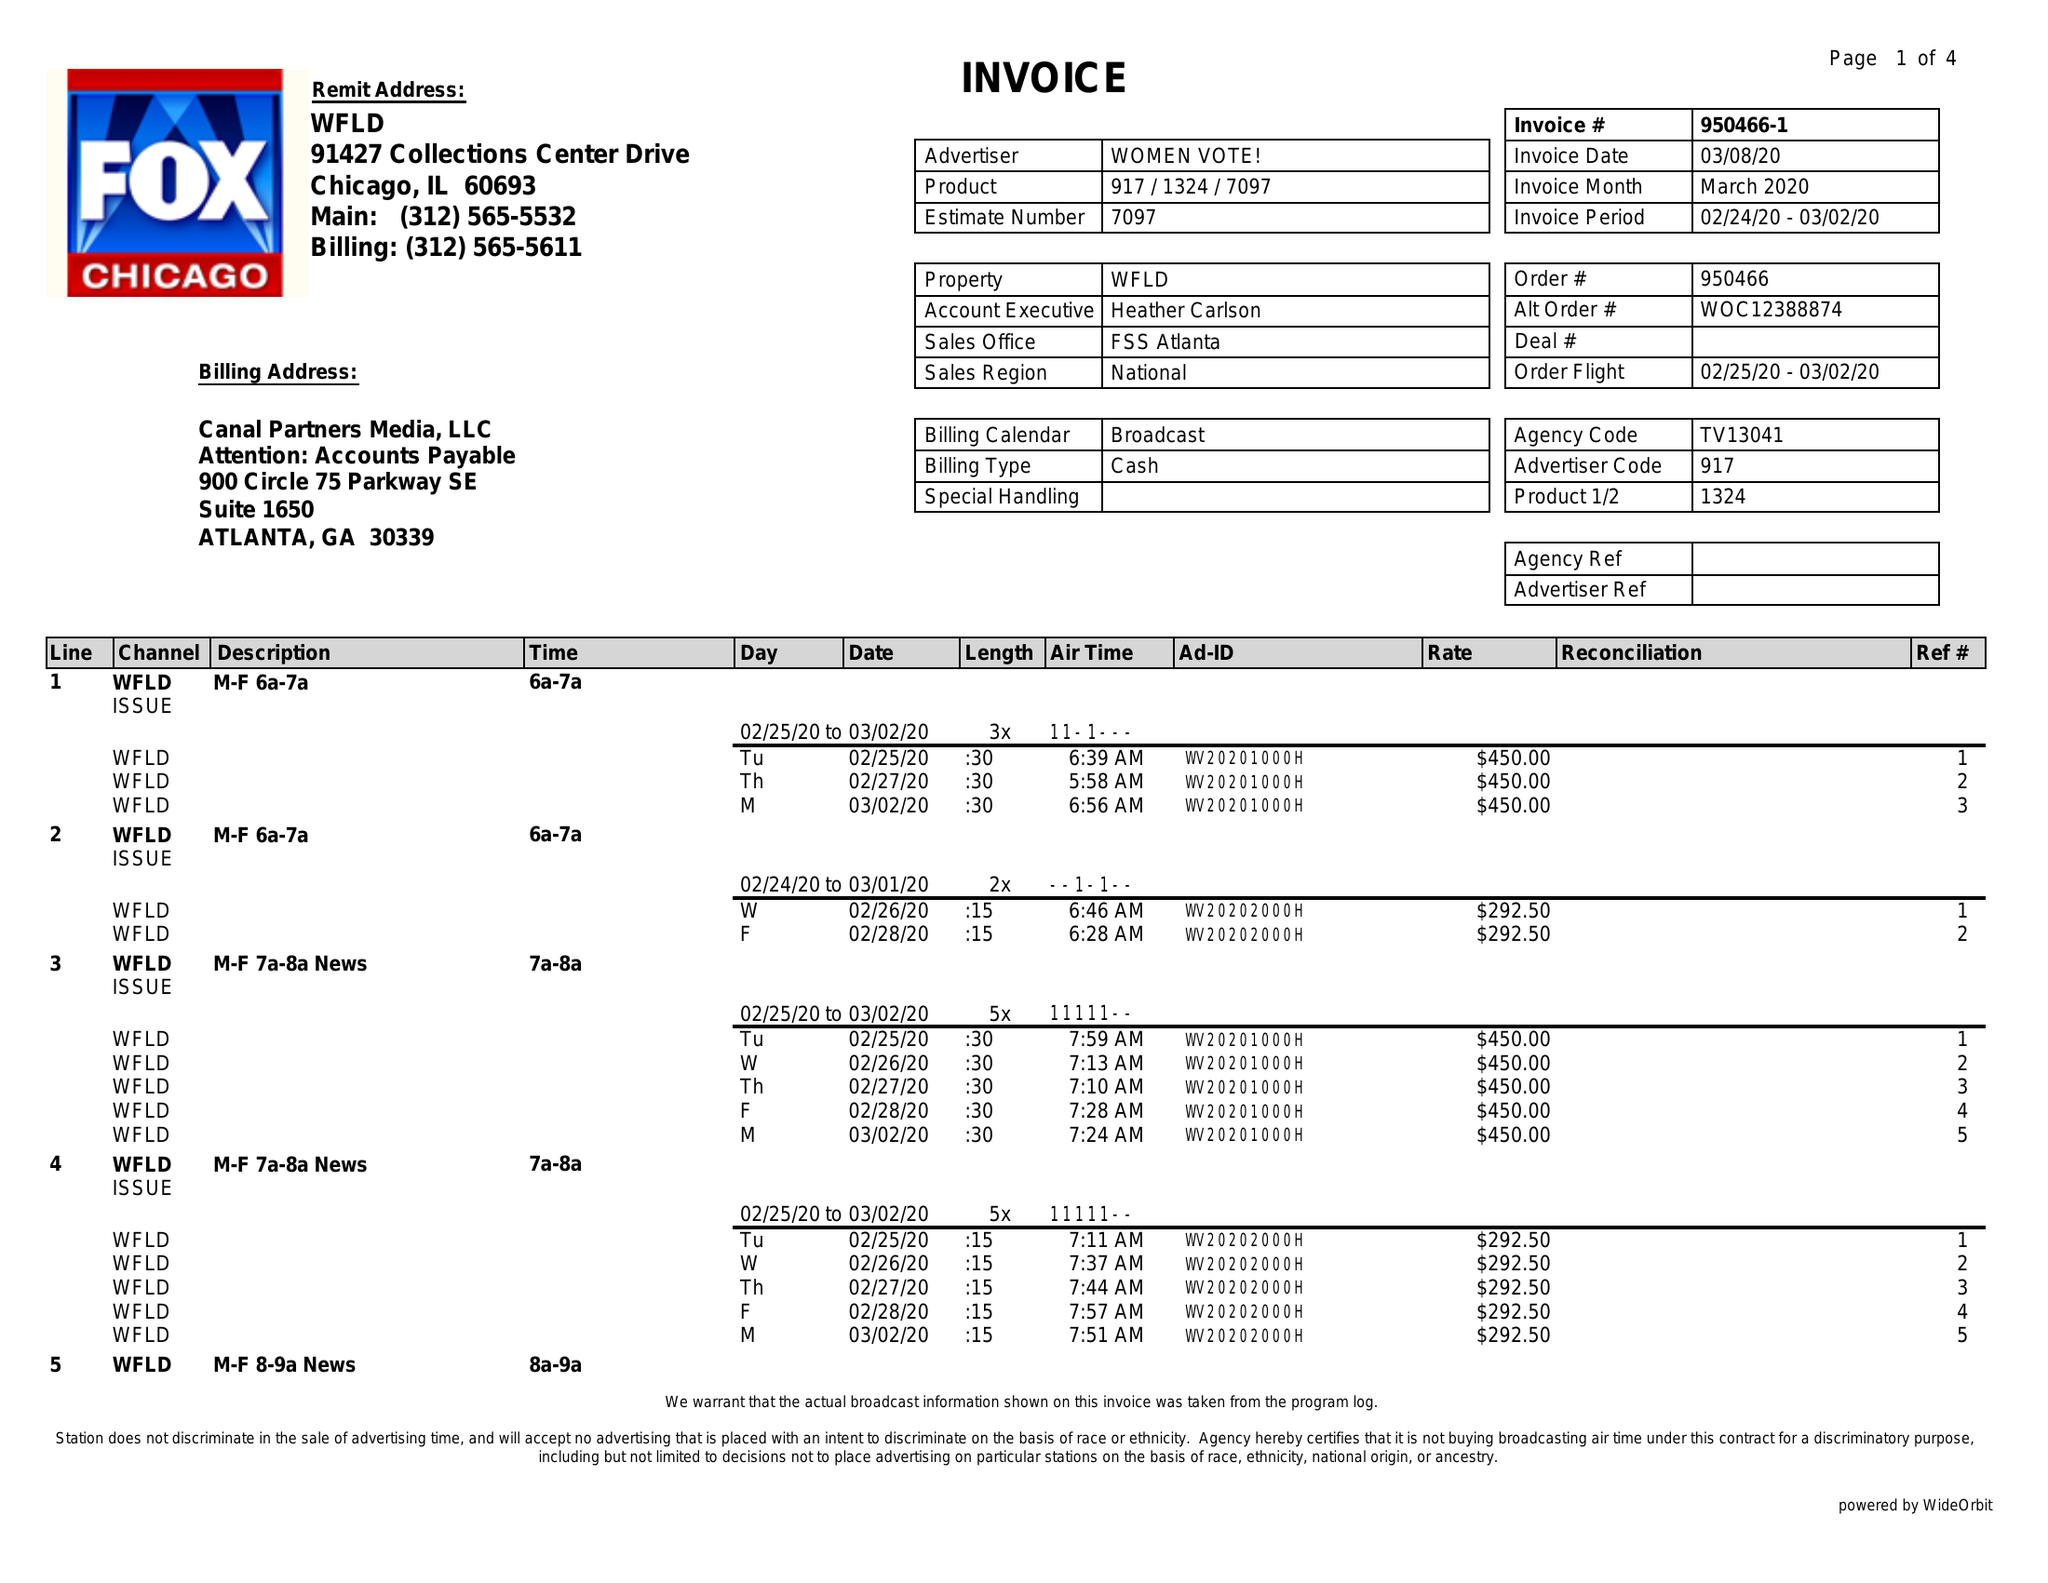What is the value for the advertiser?
Answer the question using a single word or phrase. WOMEN VOTE! 